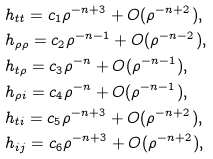Convert formula to latex. <formula><loc_0><loc_0><loc_500><loc_500>& h _ { t t } = { c _ { 1 } } \rho ^ { - n + 3 } + O ( \rho ^ { - n + 2 } ) , \\ & h _ { \rho \rho } = { c _ { 2 } } { \rho ^ { - n - 1 } } + O ( \rho ^ { - n - 2 } ) , \\ & h _ { t \rho } = c _ { 3 } \rho ^ { - n } + O ( \rho ^ { - n - 1 } ) , \\ & h _ { \rho i } = c _ { 4 } \rho ^ { - n } + O ( \rho ^ { - n - 1 } ) , \\ & h _ { t i } = c _ { 5 } \rho ^ { - n + 3 } + O ( \rho ^ { - n + 2 } ) , \\ & h _ { i j } = c _ { 6 } \rho ^ { - n + 3 } + O ( \rho ^ { - n + 2 } ) ,</formula> 